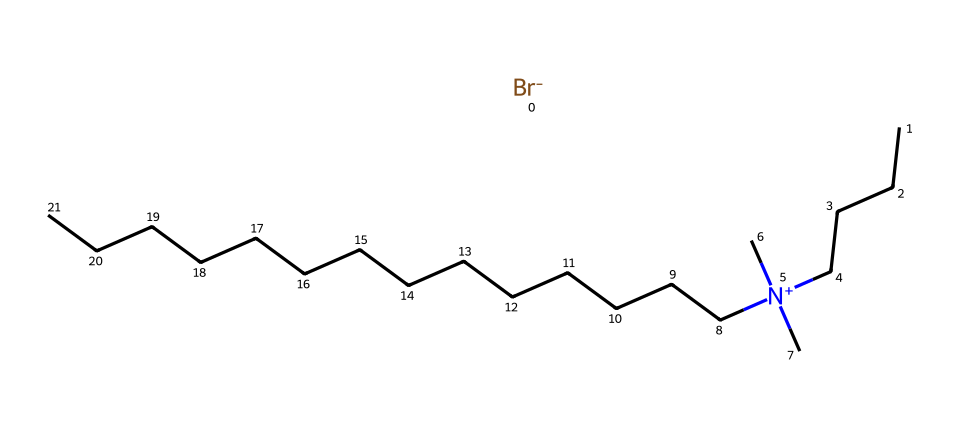How many carbon atoms are in cetrimide? By analyzing the SMILES representation, we count the carbon atoms present in the linear chains. There are 17 carbon atoms indicated in the structure.
Answer: 17 What type of ion is present in cetrimide? The SMILES includes "[Br-]", which indicates a bromide ion. Therefore, cetrimide contains a bromide ion substituent.
Answer: bromide Does cetrimide have a hydrophilic or hydrophobic character? The presence of a long hydrophobic carbon chain and a quaternary ammonium group suggests cetrimide exhibits both hydrophobic and hydrophilic characteristics, with the quaternary ammonium providing the hydrophilic properties.
Answer: amphiphilic How many nitrogen atoms are in cetrimide? The structural formula reveals one nitrogen atom that is clearly identified as part of the quaternary ammonium group.
Answer: 1 What structural feature allows cetrimide to act as a surfactant? The arrangement of carbon chains alongside the quaternary ammonium group enables cetrimide to lower surface tension, characterizing it as a surfactant.
Answer: amphiphilic structure Which type of chemical bond is present between the nitrogen and the carbon in cetrimide? The connection between the nitrogen and carbon atoms occurs through covalent bonds, as seen in the structural formula where they share electrons.
Answer: covalent What does the presence of the quaternary ammonium group in cetrimide suggest about its antimicrobial properties? The quaternary ammonium group typically enhances the antimicrobial activity due to its cationic nature, allowing it to interact effectively with microbial cell membranes.
Answer: antimicrobial activity 